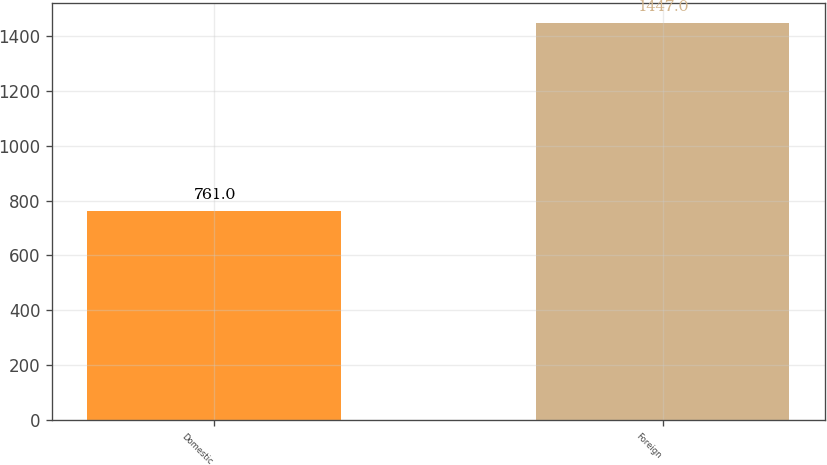Convert chart. <chart><loc_0><loc_0><loc_500><loc_500><bar_chart><fcel>Domestic<fcel>Foreign<nl><fcel>761<fcel>1447<nl></chart> 